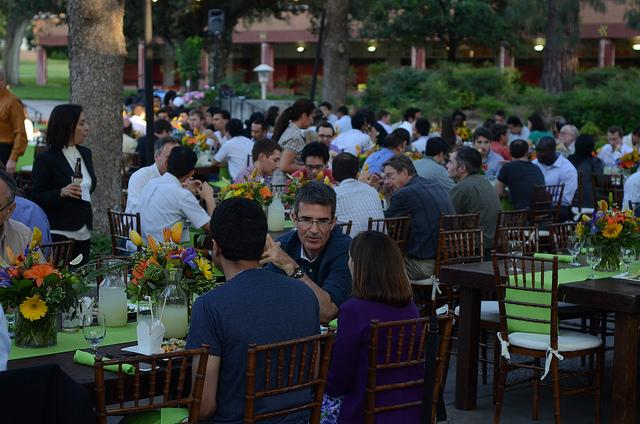What type of event is this? party 